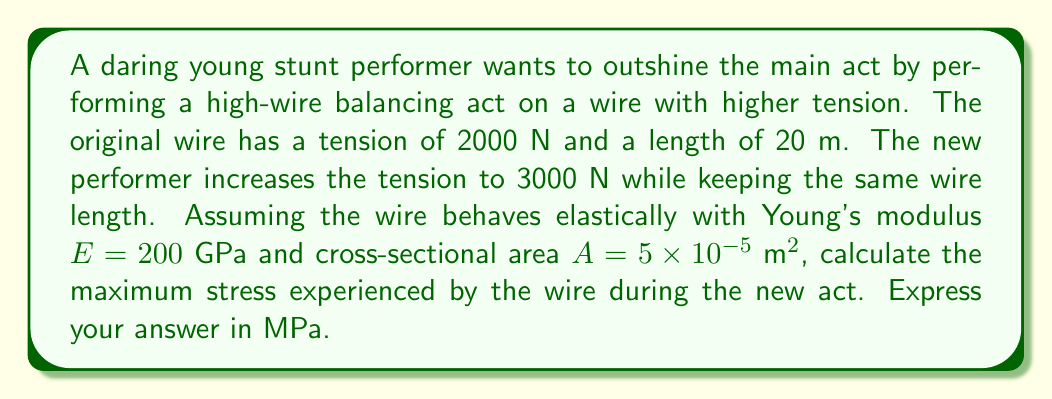Give your solution to this math problem. To solve this problem, we'll use the elasticity equations, specifically Hooke's law and the stress-strain relationship. Let's approach this step-by-step:

1) First, we need to calculate the strain in the wire due to the increased tension. The strain $\varepsilon$ is given by:

   $$\varepsilon = \frac{\Delta L}{L}$$

   where $\Delta L$ is the change in length and $L$ is the original length.

2) We can find $\Delta L$ using Hooke's law:

   $$F = k\Delta L$$

   where $F$ is the force (tension) and $k$ is the spring constant of the wire.

3) The spring constant $k$ is related to the Young's modulus $E$, cross-sectional area $A$, and length $L$ by:

   $$k = \frac{EA}{L}$$

4) Substituting this into Hooke's law:

   $$F = \frac{EA}{L}\Delta L$$

5) Solving for $\Delta L$:

   $$\Delta L = \frac{FL}{EA}$$

6) The change in force $\Delta F$ is 3000 N - 2000 N = 1000 N. Substituting the values:

   $$\Delta L = \frac{1000 \text{ N} \times 20 \text{ m}}{200 \times 10^9 \text{ Pa} \times 5 \times 10^{-5} \text{ m}^2} = 2 \times 10^{-3} \text{ m}$$

7) Now we can calculate the strain:

   $$\varepsilon = \frac{2 \times 10^{-3} \text{ m}}{20 \text{ m}} = 1 \times 10^{-4}$$

8) The stress $\sigma$ is related to strain by Young's modulus:

   $$\sigma = E\varepsilon$$

9) Substituting the values:

   $$\sigma = 200 \times 10^9 \text{ Pa} \times 1 \times 10^{-4} = 20 \times 10^6 \text{ Pa} = 20 \text{ MPa}$$

This is the additional stress due to the increased tension. The total stress will be this plus the initial stress.

10) The initial stress can be calculated as force divided by area:

    $$\sigma_{\text{initial}} = \frac{F}{A} = \frac{2000 \text{ N}}{5 \times 10^{-5} \text{ m}^2} = 40 \times 10^6 \text{ Pa} = 40 \text{ MPa}$$

11) The total maximum stress is therefore:

    $$\sigma_{\text{total}} = 20 \text{ MPa} + 40 \text{ MPa} = 60 \text{ MPa}$$
Answer: The maximum stress experienced by the wire during the new act is 60 MPa. 